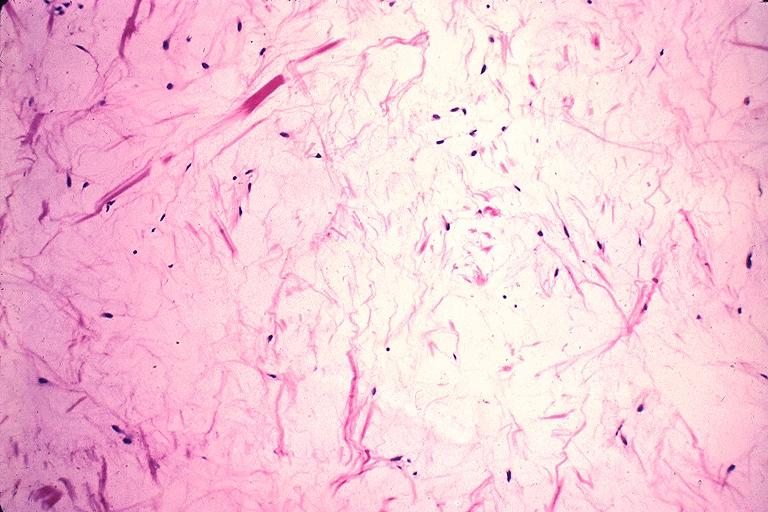what is present?
Answer the question using a single word or phrase. Oral 